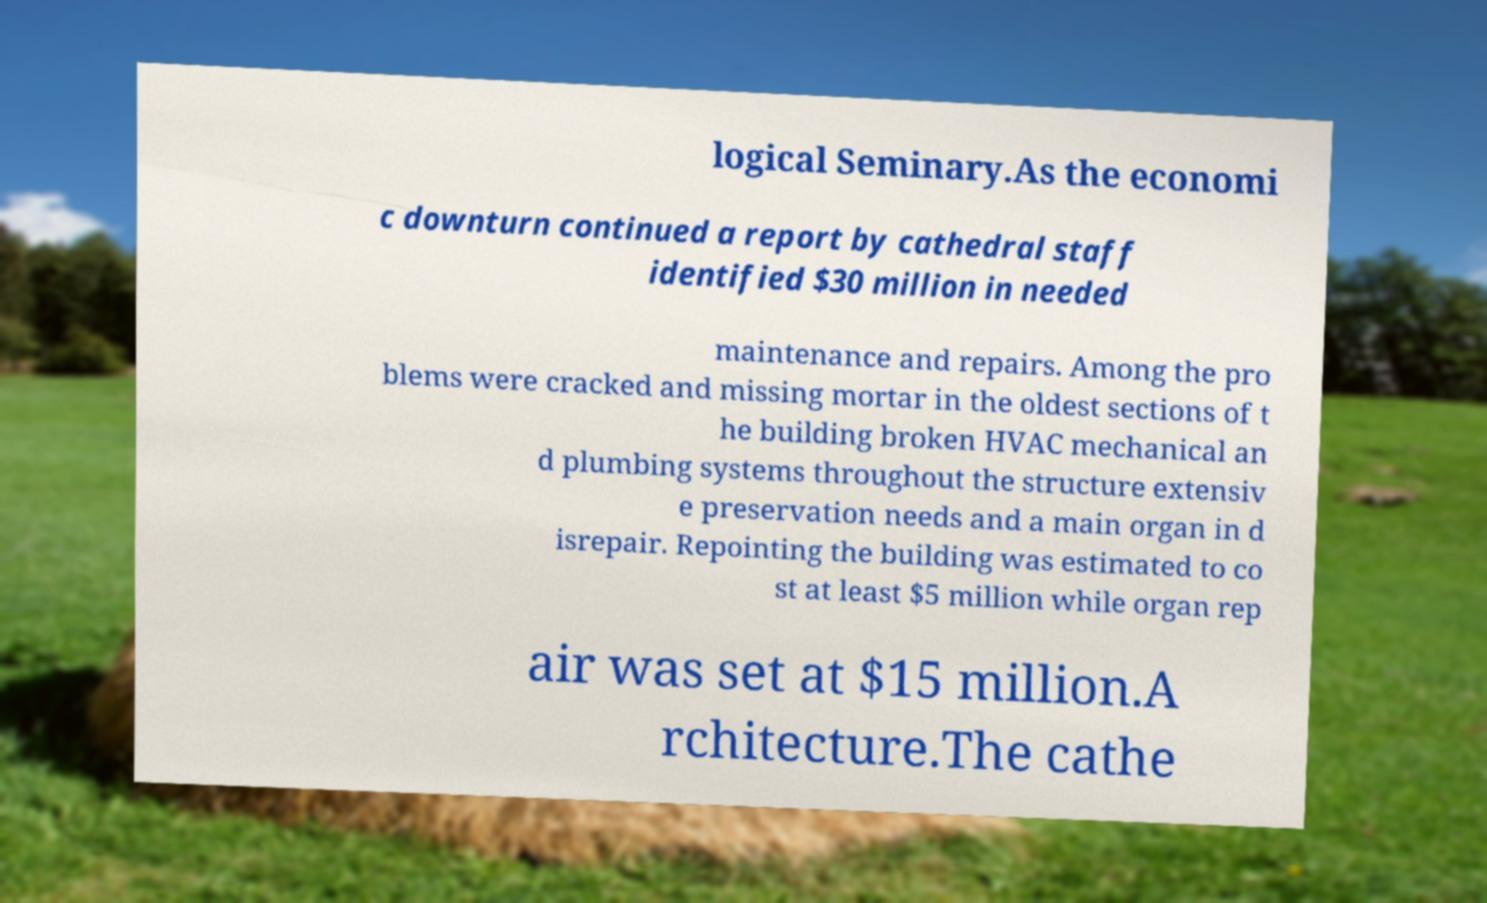For documentation purposes, I need the text within this image transcribed. Could you provide that? logical Seminary.As the economi c downturn continued a report by cathedral staff identified $30 million in needed maintenance and repairs. Among the pro blems were cracked and missing mortar in the oldest sections of t he building broken HVAC mechanical an d plumbing systems throughout the structure extensiv e preservation needs and a main organ in d isrepair. Repointing the building was estimated to co st at least $5 million while organ rep air was set at $15 million.A rchitecture.The cathe 